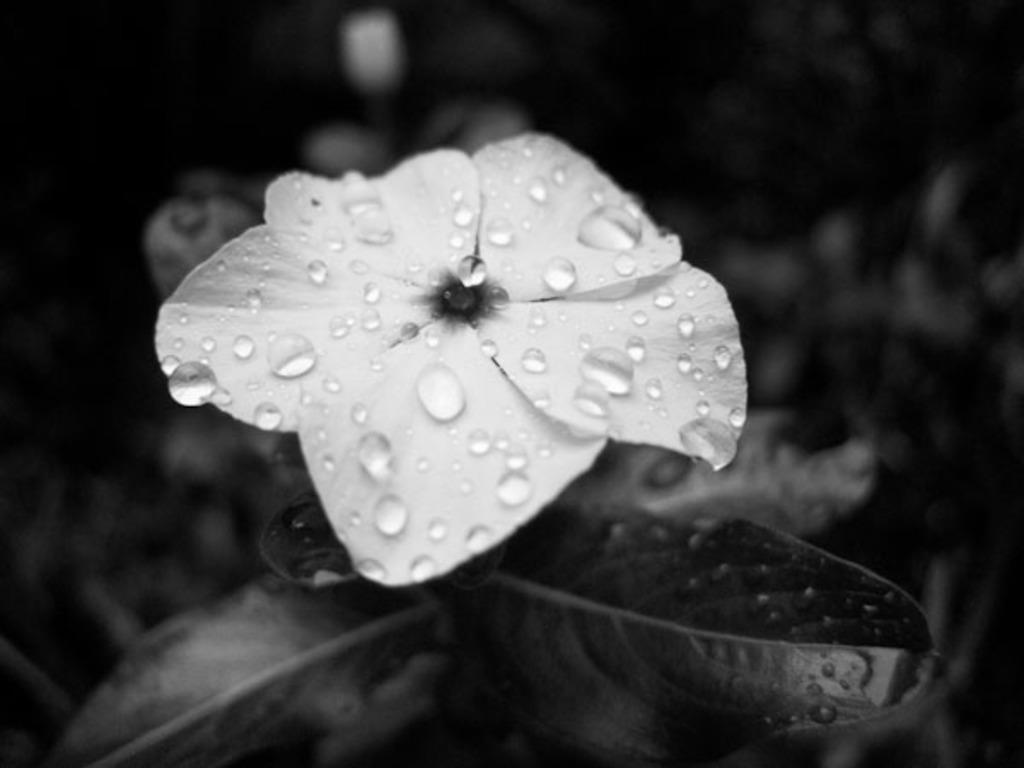In one or two sentences, can you explain what this image depicts? As we can see in the image there is a plant and white color flower. On flower there are water drops. The image is little dark. 